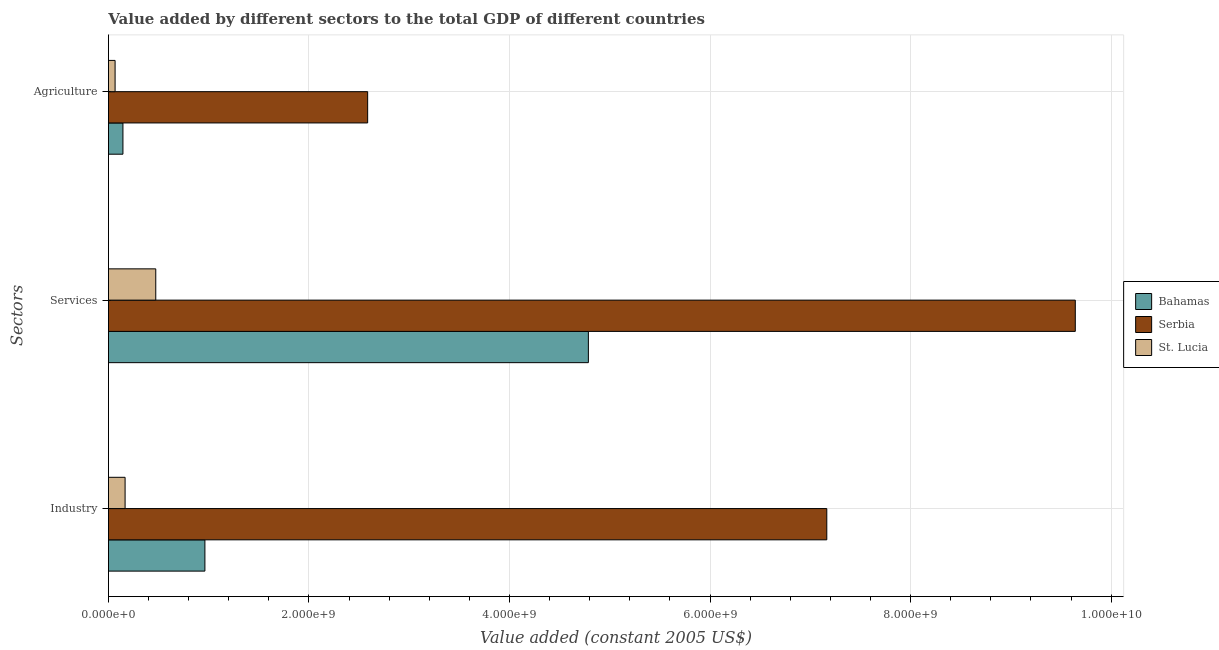How many different coloured bars are there?
Ensure brevity in your answer.  3. How many groups of bars are there?
Your answer should be very brief. 3. What is the label of the 3rd group of bars from the top?
Offer a very short reply. Industry. What is the value added by agricultural sector in Bahamas?
Provide a short and direct response. 1.45e+08. Across all countries, what is the maximum value added by industrial sector?
Keep it short and to the point. 7.16e+09. Across all countries, what is the minimum value added by services?
Offer a very short reply. 4.72e+08. In which country was the value added by services maximum?
Ensure brevity in your answer.  Serbia. In which country was the value added by industrial sector minimum?
Offer a very short reply. St. Lucia. What is the total value added by agricultural sector in the graph?
Your answer should be compact. 2.80e+09. What is the difference between the value added by services in St. Lucia and that in Bahamas?
Provide a short and direct response. -4.31e+09. What is the difference between the value added by agricultural sector in Bahamas and the value added by services in St. Lucia?
Ensure brevity in your answer.  -3.27e+08. What is the average value added by agricultural sector per country?
Give a very brief answer. 9.32e+08. What is the difference between the value added by services and value added by agricultural sector in Bahamas?
Provide a short and direct response. 4.64e+09. What is the ratio of the value added by services in St. Lucia to that in Serbia?
Your response must be concise. 0.05. What is the difference between the highest and the second highest value added by services?
Provide a succinct answer. 4.86e+09. What is the difference between the highest and the lowest value added by agricultural sector?
Your answer should be very brief. 2.52e+09. In how many countries, is the value added by agricultural sector greater than the average value added by agricultural sector taken over all countries?
Ensure brevity in your answer.  1. What does the 1st bar from the top in Services represents?
Keep it short and to the point. St. Lucia. What does the 1st bar from the bottom in Industry represents?
Offer a terse response. Bahamas. Is it the case that in every country, the sum of the value added by industrial sector and value added by services is greater than the value added by agricultural sector?
Keep it short and to the point. Yes. How many bars are there?
Your response must be concise. 9. Are all the bars in the graph horizontal?
Offer a terse response. Yes. How many countries are there in the graph?
Give a very brief answer. 3. What is the difference between two consecutive major ticks on the X-axis?
Offer a terse response. 2.00e+09. Are the values on the major ticks of X-axis written in scientific E-notation?
Your answer should be compact. Yes. How many legend labels are there?
Offer a terse response. 3. What is the title of the graph?
Offer a terse response. Value added by different sectors to the total GDP of different countries. What is the label or title of the X-axis?
Provide a short and direct response. Value added (constant 2005 US$). What is the label or title of the Y-axis?
Your answer should be very brief. Sectors. What is the Value added (constant 2005 US$) of Bahamas in Industry?
Your answer should be very brief. 9.62e+08. What is the Value added (constant 2005 US$) of Serbia in Industry?
Your answer should be compact. 7.16e+09. What is the Value added (constant 2005 US$) in St. Lucia in Industry?
Provide a succinct answer. 1.66e+08. What is the Value added (constant 2005 US$) in Bahamas in Services?
Offer a terse response. 4.79e+09. What is the Value added (constant 2005 US$) of Serbia in Services?
Ensure brevity in your answer.  9.64e+09. What is the Value added (constant 2005 US$) of St. Lucia in Services?
Give a very brief answer. 4.72e+08. What is the Value added (constant 2005 US$) in Bahamas in Agriculture?
Your answer should be very brief. 1.45e+08. What is the Value added (constant 2005 US$) of Serbia in Agriculture?
Your answer should be compact. 2.59e+09. What is the Value added (constant 2005 US$) of St. Lucia in Agriculture?
Provide a short and direct response. 6.65e+07. Across all Sectors, what is the maximum Value added (constant 2005 US$) of Bahamas?
Offer a terse response. 4.79e+09. Across all Sectors, what is the maximum Value added (constant 2005 US$) in Serbia?
Ensure brevity in your answer.  9.64e+09. Across all Sectors, what is the maximum Value added (constant 2005 US$) of St. Lucia?
Your answer should be compact. 4.72e+08. Across all Sectors, what is the minimum Value added (constant 2005 US$) of Bahamas?
Keep it short and to the point. 1.45e+08. Across all Sectors, what is the minimum Value added (constant 2005 US$) in Serbia?
Your response must be concise. 2.59e+09. Across all Sectors, what is the minimum Value added (constant 2005 US$) in St. Lucia?
Ensure brevity in your answer.  6.65e+07. What is the total Value added (constant 2005 US$) in Bahamas in the graph?
Provide a succinct answer. 5.89e+09. What is the total Value added (constant 2005 US$) in Serbia in the graph?
Your answer should be very brief. 1.94e+1. What is the total Value added (constant 2005 US$) of St. Lucia in the graph?
Your answer should be very brief. 7.05e+08. What is the difference between the Value added (constant 2005 US$) of Bahamas in Industry and that in Services?
Give a very brief answer. -3.82e+09. What is the difference between the Value added (constant 2005 US$) of Serbia in Industry and that in Services?
Offer a very short reply. -2.48e+09. What is the difference between the Value added (constant 2005 US$) of St. Lucia in Industry and that in Services?
Provide a short and direct response. -3.06e+08. What is the difference between the Value added (constant 2005 US$) of Bahamas in Industry and that in Agriculture?
Your answer should be compact. 8.18e+08. What is the difference between the Value added (constant 2005 US$) in Serbia in Industry and that in Agriculture?
Make the answer very short. 4.58e+09. What is the difference between the Value added (constant 2005 US$) of St. Lucia in Industry and that in Agriculture?
Keep it short and to the point. 9.96e+07. What is the difference between the Value added (constant 2005 US$) of Bahamas in Services and that in Agriculture?
Provide a succinct answer. 4.64e+09. What is the difference between the Value added (constant 2005 US$) in Serbia in Services and that in Agriculture?
Your answer should be compact. 7.06e+09. What is the difference between the Value added (constant 2005 US$) in St. Lucia in Services and that in Agriculture?
Provide a short and direct response. 4.06e+08. What is the difference between the Value added (constant 2005 US$) in Bahamas in Industry and the Value added (constant 2005 US$) in Serbia in Services?
Give a very brief answer. -8.68e+09. What is the difference between the Value added (constant 2005 US$) of Bahamas in Industry and the Value added (constant 2005 US$) of St. Lucia in Services?
Your response must be concise. 4.90e+08. What is the difference between the Value added (constant 2005 US$) in Serbia in Industry and the Value added (constant 2005 US$) in St. Lucia in Services?
Your response must be concise. 6.69e+09. What is the difference between the Value added (constant 2005 US$) in Bahamas in Industry and the Value added (constant 2005 US$) in Serbia in Agriculture?
Your answer should be compact. -1.62e+09. What is the difference between the Value added (constant 2005 US$) in Bahamas in Industry and the Value added (constant 2005 US$) in St. Lucia in Agriculture?
Offer a terse response. 8.96e+08. What is the difference between the Value added (constant 2005 US$) of Serbia in Industry and the Value added (constant 2005 US$) of St. Lucia in Agriculture?
Your answer should be compact. 7.10e+09. What is the difference between the Value added (constant 2005 US$) in Bahamas in Services and the Value added (constant 2005 US$) in Serbia in Agriculture?
Offer a very short reply. 2.20e+09. What is the difference between the Value added (constant 2005 US$) in Bahamas in Services and the Value added (constant 2005 US$) in St. Lucia in Agriculture?
Your answer should be compact. 4.72e+09. What is the difference between the Value added (constant 2005 US$) of Serbia in Services and the Value added (constant 2005 US$) of St. Lucia in Agriculture?
Your answer should be very brief. 9.58e+09. What is the average Value added (constant 2005 US$) in Bahamas per Sectors?
Ensure brevity in your answer.  1.96e+09. What is the average Value added (constant 2005 US$) in Serbia per Sectors?
Ensure brevity in your answer.  6.46e+09. What is the average Value added (constant 2005 US$) of St. Lucia per Sectors?
Provide a succinct answer. 2.35e+08. What is the difference between the Value added (constant 2005 US$) in Bahamas and Value added (constant 2005 US$) in Serbia in Industry?
Provide a short and direct response. -6.20e+09. What is the difference between the Value added (constant 2005 US$) of Bahamas and Value added (constant 2005 US$) of St. Lucia in Industry?
Give a very brief answer. 7.96e+08. What is the difference between the Value added (constant 2005 US$) in Serbia and Value added (constant 2005 US$) in St. Lucia in Industry?
Your response must be concise. 7.00e+09. What is the difference between the Value added (constant 2005 US$) in Bahamas and Value added (constant 2005 US$) in Serbia in Services?
Your response must be concise. -4.86e+09. What is the difference between the Value added (constant 2005 US$) of Bahamas and Value added (constant 2005 US$) of St. Lucia in Services?
Make the answer very short. 4.31e+09. What is the difference between the Value added (constant 2005 US$) in Serbia and Value added (constant 2005 US$) in St. Lucia in Services?
Ensure brevity in your answer.  9.17e+09. What is the difference between the Value added (constant 2005 US$) of Bahamas and Value added (constant 2005 US$) of Serbia in Agriculture?
Your response must be concise. -2.44e+09. What is the difference between the Value added (constant 2005 US$) in Bahamas and Value added (constant 2005 US$) in St. Lucia in Agriculture?
Provide a succinct answer. 7.81e+07. What is the difference between the Value added (constant 2005 US$) of Serbia and Value added (constant 2005 US$) of St. Lucia in Agriculture?
Your answer should be compact. 2.52e+09. What is the ratio of the Value added (constant 2005 US$) in Bahamas in Industry to that in Services?
Keep it short and to the point. 0.2. What is the ratio of the Value added (constant 2005 US$) in Serbia in Industry to that in Services?
Your response must be concise. 0.74. What is the ratio of the Value added (constant 2005 US$) of St. Lucia in Industry to that in Services?
Offer a very short reply. 0.35. What is the ratio of the Value added (constant 2005 US$) of Bahamas in Industry to that in Agriculture?
Ensure brevity in your answer.  6.65. What is the ratio of the Value added (constant 2005 US$) in Serbia in Industry to that in Agriculture?
Keep it short and to the point. 2.77. What is the ratio of the Value added (constant 2005 US$) of St. Lucia in Industry to that in Agriculture?
Provide a succinct answer. 2.5. What is the ratio of the Value added (constant 2005 US$) of Bahamas in Services to that in Agriculture?
Ensure brevity in your answer.  33.09. What is the ratio of the Value added (constant 2005 US$) of Serbia in Services to that in Agriculture?
Your answer should be very brief. 3.73. What is the ratio of the Value added (constant 2005 US$) in St. Lucia in Services to that in Agriculture?
Make the answer very short. 7.1. What is the difference between the highest and the second highest Value added (constant 2005 US$) in Bahamas?
Make the answer very short. 3.82e+09. What is the difference between the highest and the second highest Value added (constant 2005 US$) of Serbia?
Offer a terse response. 2.48e+09. What is the difference between the highest and the second highest Value added (constant 2005 US$) of St. Lucia?
Offer a terse response. 3.06e+08. What is the difference between the highest and the lowest Value added (constant 2005 US$) in Bahamas?
Offer a very short reply. 4.64e+09. What is the difference between the highest and the lowest Value added (constant 2005 US$) of Serbia?
Give a very brief answer. 7.06e+09. What is the difference between the highest and the lowest Value added (constant 2005 US$) in St. Lucia?
Your response must be concise. 4.06e+08. 